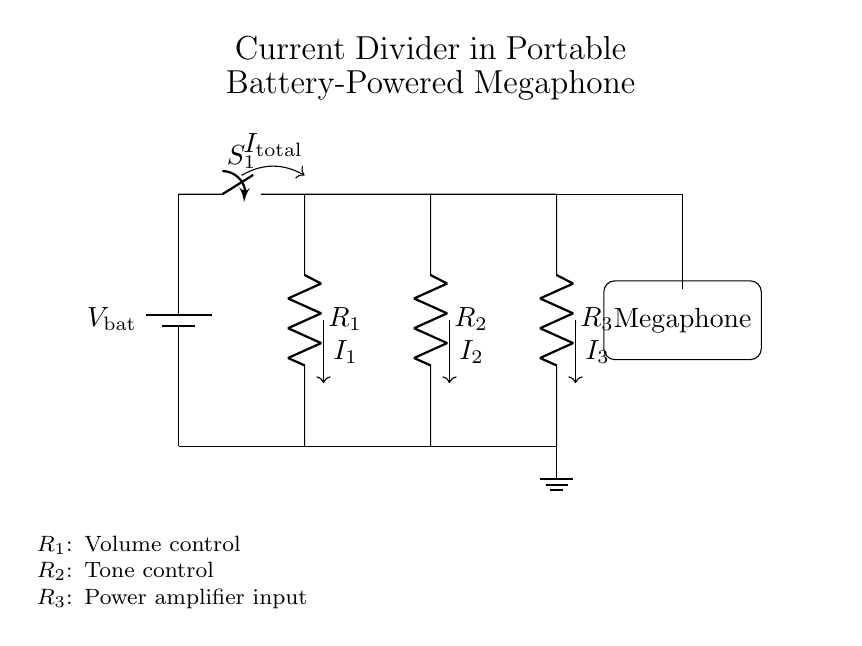What is the total current entering the current divider? The total current entering the current divider is denoted as I total, which represents the sum of the currents flowing through the individual resistors in the divider.
Answer: I total What are the components labeled in the circuit? The components labeled in the circuit include a battery, a switch, three resistors (R1, R2, and R3), and a megaphone. Each of these components plays a specific role in the functionality of the circuit.
Answer: Battery, switch, R1, R2, R3, megaphone What does resistor R1 control in the circuit? Resistor R1 is labeled as volume control, indicating its function is to adjust the loudness of the sound emitted from the megaphone.
Answer: Volume control How many resistors are in the current divider configuration? There are three resistors (R1, R2, and R3) in the current divider configuration, as indicated in the circuit diagram and their labels.
Answer: Three If the resistance of R2 is increased, what happens to I2? If the resistance of R2 is increased, according to the current divider rule, I2 (the current through R2) will decrease, because a higher resistance in the branch will result in less current flowing through it when the total voltage remains constant.
Answer: Decreases What is the role of the megaphone in this circuit? The role of the megaphone in this circuit is to amplify and project sound, making it a critical component for communication in resistance movements where loud messaging is needed.
Answer: Amplify sound 